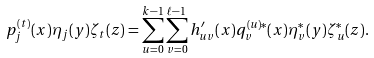<formula> <loc_0><loc_0><loc_500><loc_500>p _ { j } ^ { ( t ) } ( x ) \eta _ { j } ( y ) \zeta _ { t } ( z ) = \sum _ { u = 0 } ^ { k - 1 } \sum _ { v = 0 } ^ { \ell - 1 } h ^ { \prime } _ { u v } ( x ) q _ { v } ^ { ( u ) * } ( x ) \eta _ { v } ^ { * } ( y ) \zeta _ { u } ^ { * } ( z ) .</formula> 